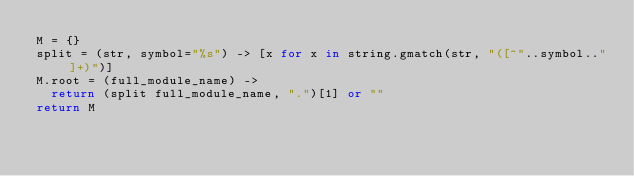Convert code to text. <code><loc_0><loc_0><loc_500><loc_500><_MoonScript_>M = {}
split = (str, symbol="%s") -> [x for x in string.gmatch(str, "([^"..symbol.."]+)")]
M.root = (full_module_name) ->
  return (split full_module_name, ".")[1] or ""
return M</code> 